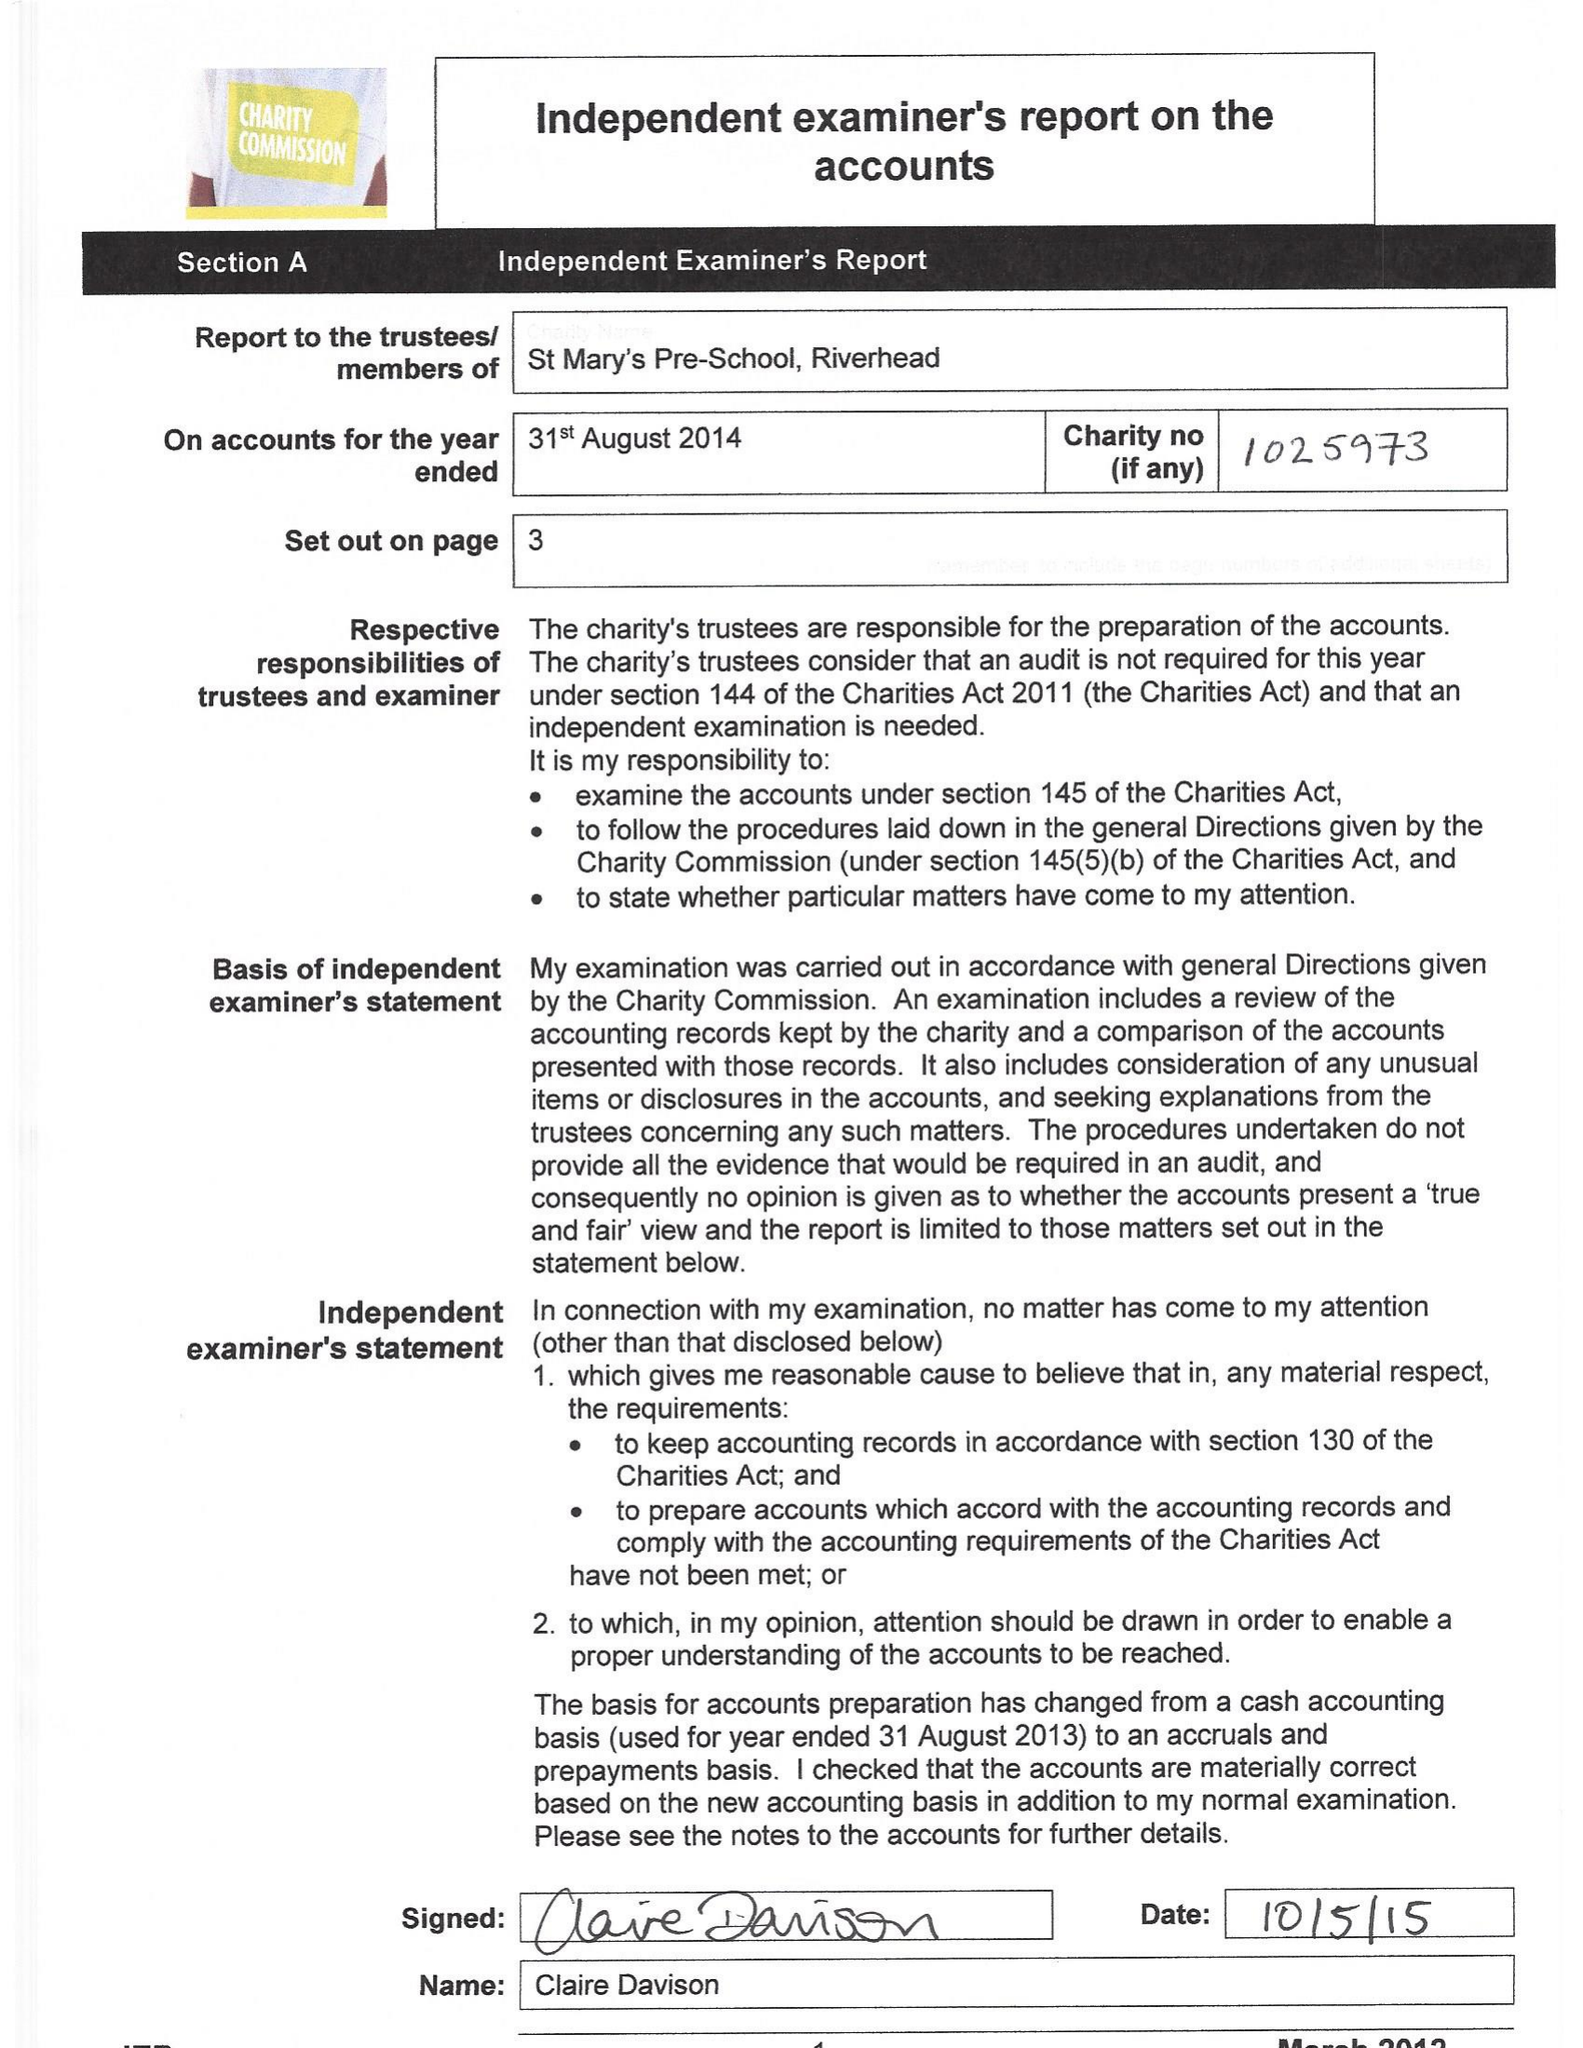What is the value for the spending_annually_in_british_pounds?
Answer the question using a single word or phrase. 70181.00 